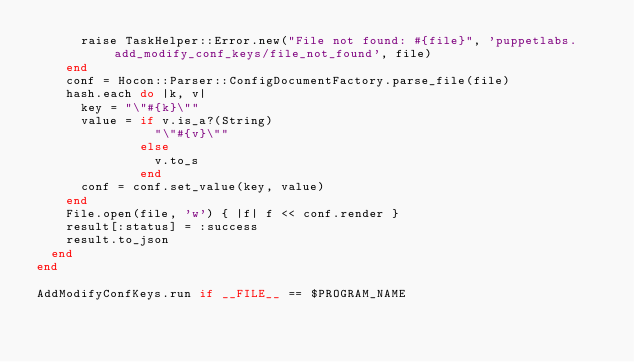Convert code to text. <code><loc_0><loc_0><loc_500><loc_500><_Ruby_>      raise TaskHelper::Error.new("File not found: #{file}", 'puppetlabs.add_modify_conf_keys/file_not_found', file)
    end
    conf = Hocon::Parser::ConfigDocumentFactory.parse_file(file)
    hash.each do |k, v|
      key = "\"#{k}\""
      value = if v.is_a?(String)
                "\"#{v}\""
              else
                v.to_s
              end
      conf = conf.set_value(key, value)
    end
    File.open(file, 'w') { |f| f << conf.render }
    result[:status] = :success
    result.to_json
  end
end

AddModifyConfKeys.run if __FILE__ == $PROGRAM_NAME
</code> 